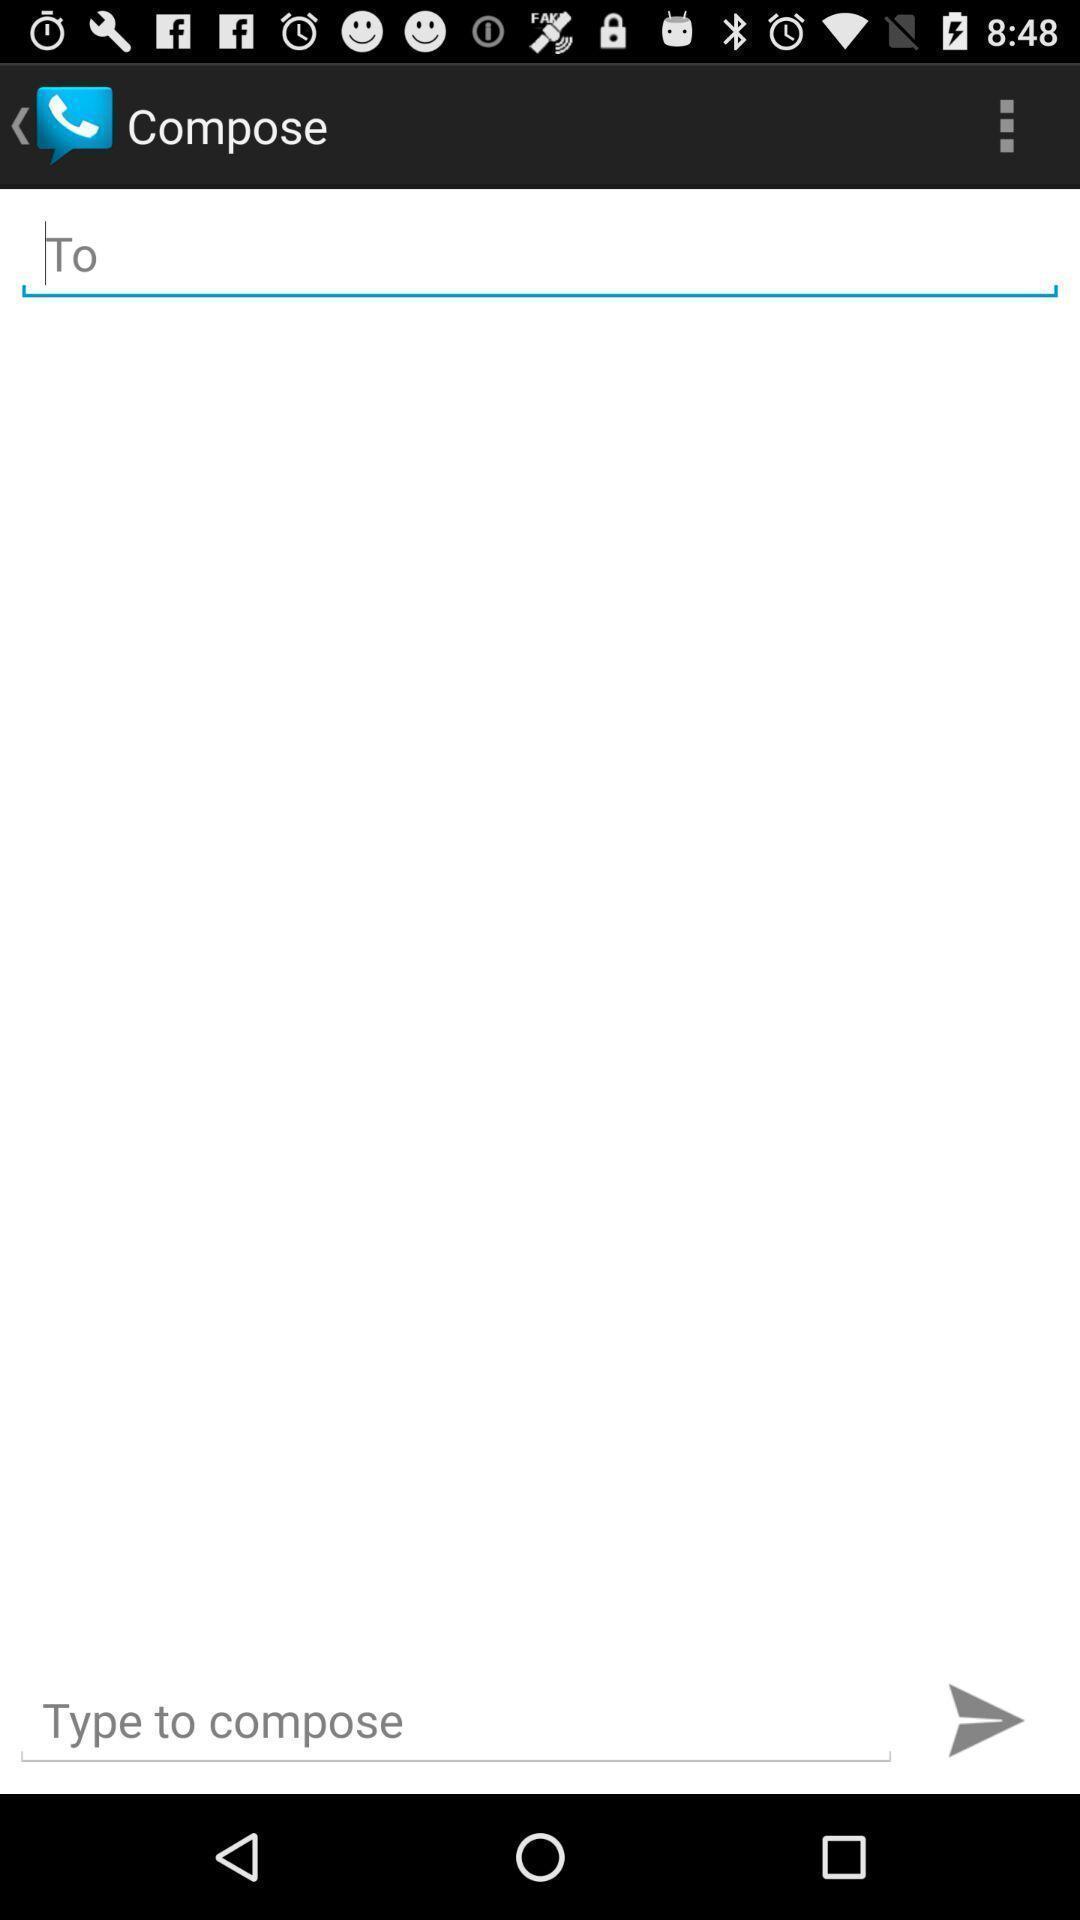Summarize the main components in this picture. Page showing option to compose message. 